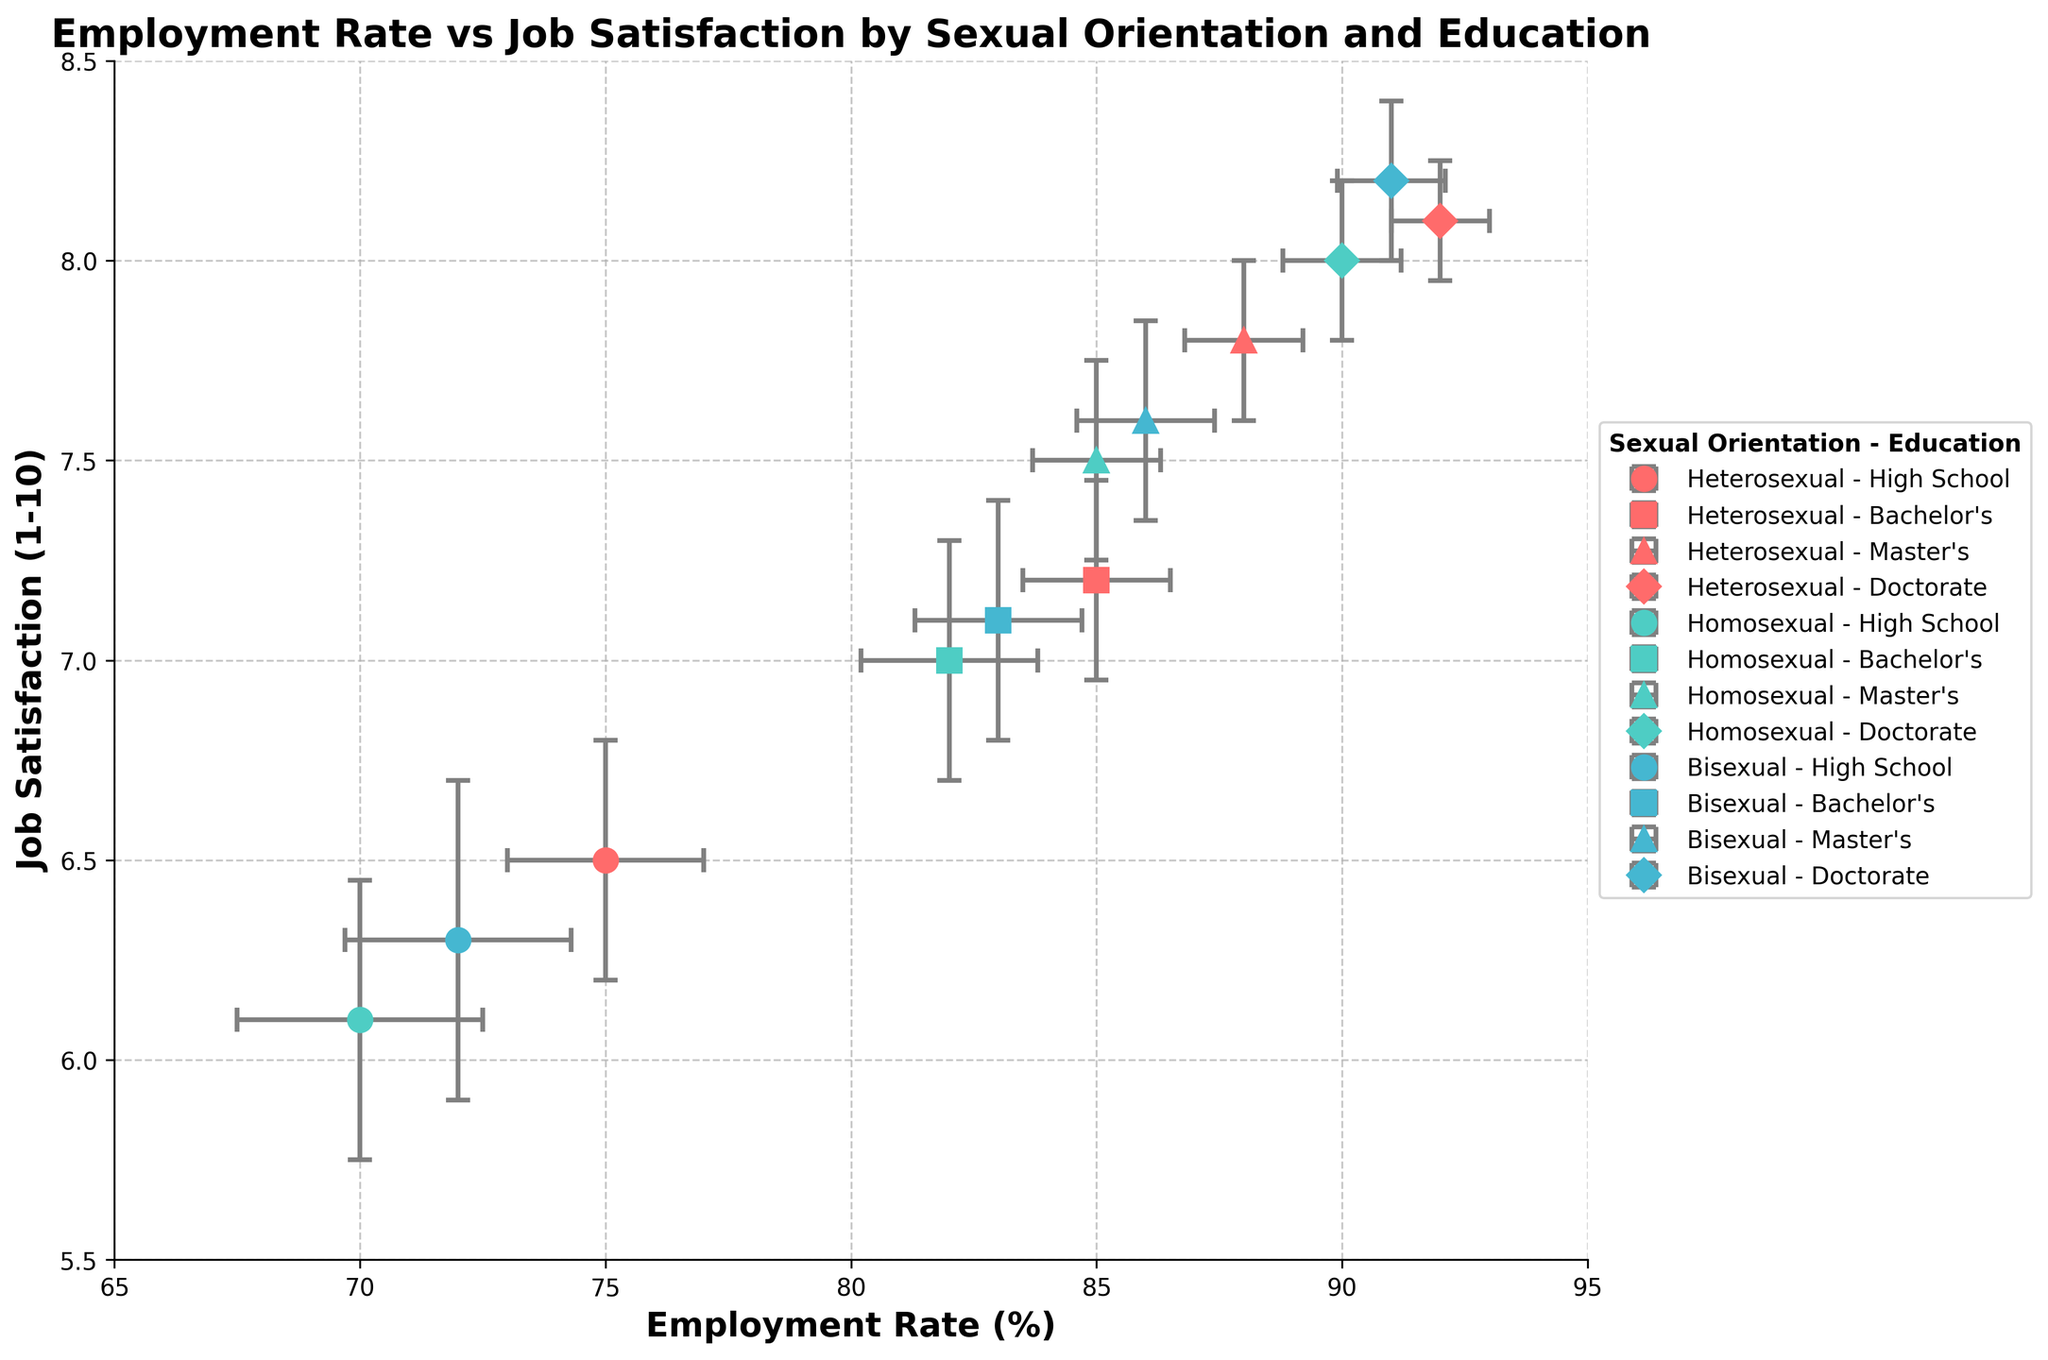How many data points are there in total on the scatter plot? Each educational background has four sexual orientations and each combination has one data point. There are 4 (High School, Bachelor's, Master's, Doctorate) * 3 (Heterosexual, Homosexual, Bisexual) = 12 data points in total.
Answer: 12 What is the title of the scatter plot? The title is located at the top of the plot and describes the main context and variables. It states "Employment Rate vs Job Satisfaction by Sexual Orientation and Education."
Answer: Employment Rate vs Job Satisfaction by Sexual Orientation and Education Which group has the highest job satisfaction? Based on the y-axis representing job satisfaction and the data points, the group with the highest job satisfaction value is Bisexual with a Doctorate, having a value of 8.2.
Answer: Bisexual with Doctorate Which group has the lowest employment rate? Refer to the x-axis which represents the employment rate and look for the lowest data point. The group with the lowest employment rate is Homosexual with High School, having a value of 70.
Answer: Homosexual with High School What is the job satisfaction for Heterosexuals with a Bachelor's degree? Find the data point corresponding to Heterosexual and Bachelor's degree, then refer to the y-axis value which represents job satisfaction. Job satisfaction is 7.2.
Answer: 7.2 What is the employment rate difference between Heterosexuals with a Master's and a Doctorate degree? Locate the employment rate for Heterosexuals with a Master's (88) and a Doctorate (92). The difference is calculated by 92 - 88 = 4.
Answer: 4 Do any two educational backgrounds share the same job satisfaction among Heterosexuals? Check the y-axis values for job satisfaction of Heterosexuals across all educational backgrounds. No two educational backgrounds have the same job satisfaction.
Answer: No How does the employment rate for Bisexuals with a High School education compare to their Bachelor's degree? Locate the employment rates on the x-axis for Bisexuals with a High School (72) and a Bachelor's degree (83), compare them: 72 is lower than 83.
Answer: Lower Which sexual orientation shows the largest increase in employment rate from High School to Master's degree? Calculate the increase for each sexual orientation from High School to Master's employment rates: 
Heterosexual: 88 - 75 = 13 
Homosexual: 85 - 70 = 15 
Bisexual: 86 - 72 = 14. 
Homosexuals show the largest increase.
Answer: Homosexual How do the error bars for employment rate compare between Heterosexuals with a Bachelor's degree and a Doctorate? Compare the length of the error bars (xerr) for these two groups. Heterosexuals with a Bachelor's degree have an error of 1.5, while with a Doctorate have 1. The Bachelor's degree group has a larger error bar than the Doctorate group.
Answer: Bachelor's larger 